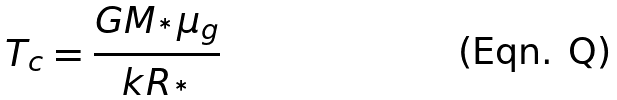<formula> <loc_0><loc_0><loc_500><loc_500>T _ { c } = \frac { G M _ { ^ { * } } \mu _ { g } } { k R _ { ^ { * } } }</formula> 